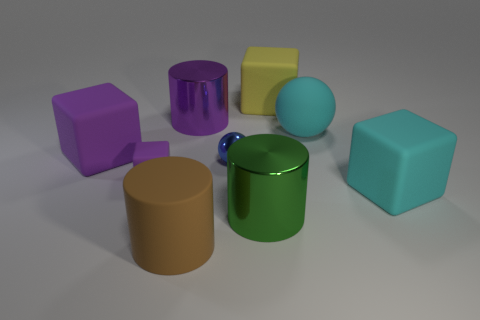Are there any shadows in the image that could tell us about the light source? Indeed, we can observe shadows cast by each object, mostly oriented towards the right of the image from the viewer's perspective. This suggests that the primary light source is positioned towards the left, likely above the objects. 